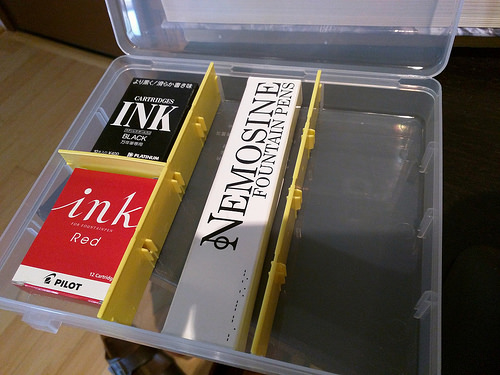<image>
Can you confirm if the red ink is to the left of the black ink? No. The red ink is not to the left of the black ink. From this viewpoint, they have a different horizontal relationship. 